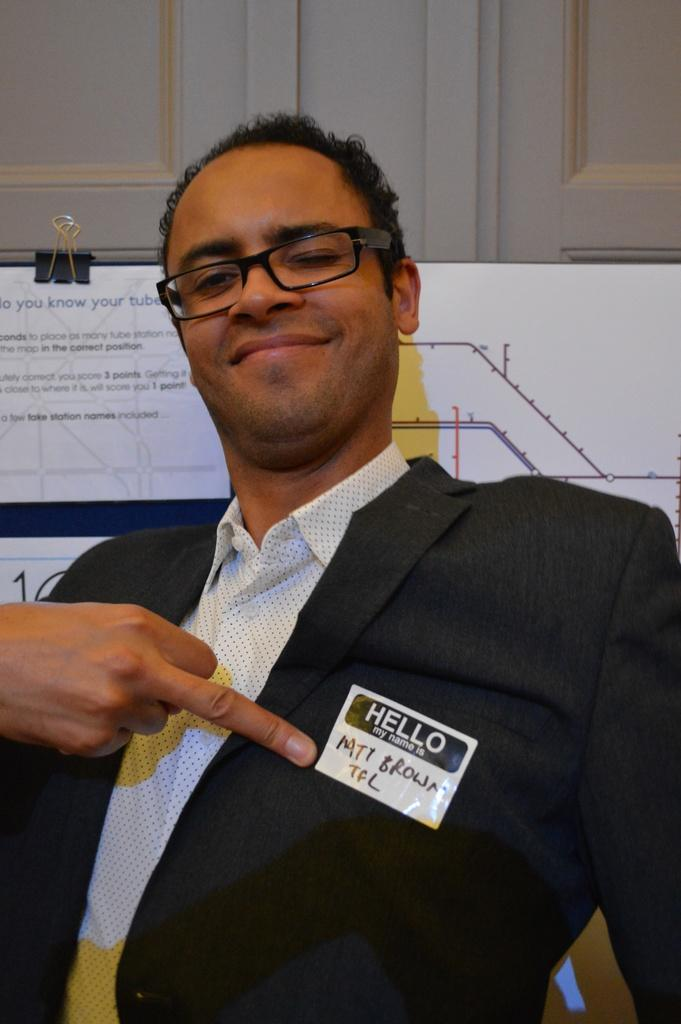What is the main subject in the foreground of the image? There is a person in the foreground of the image. What can be observed about the person's appearance? The person is wearing spectacles and a suit. What is present on the board in the image? There is a board with text in the image. What can be seen behind the person in the image? The background of the image appears to be a wall. What type of breakfast is the person eating in the image? There is no breakfast present in the image; it only features a person, spectacles, a suit, a board with text, and a wall in the background. 